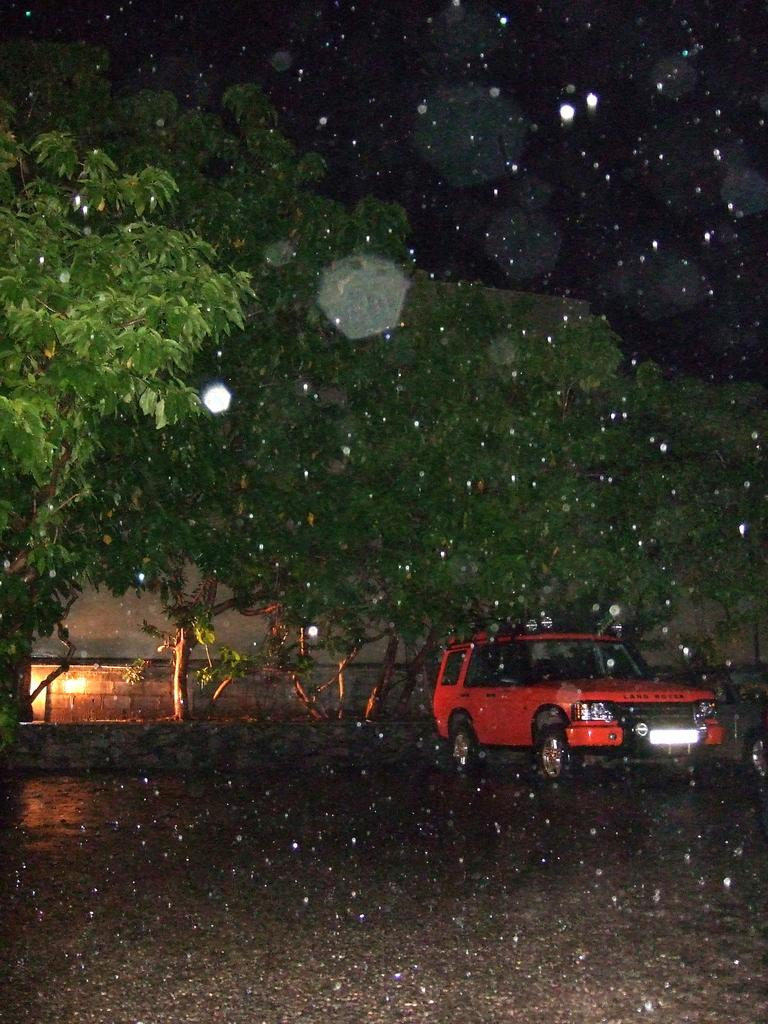What is parked on the road in the image? There is a vehicle parked on the road in the image. What can be seen in the background of the image? There is a group of trees and light visible in the background of the image. What else is visible in the background of the image? The sky is visible in the background of the image. What type of plastic is used to make the coach in the image? There is no coach present in the image, and therefore no plastic can be associated with it. 